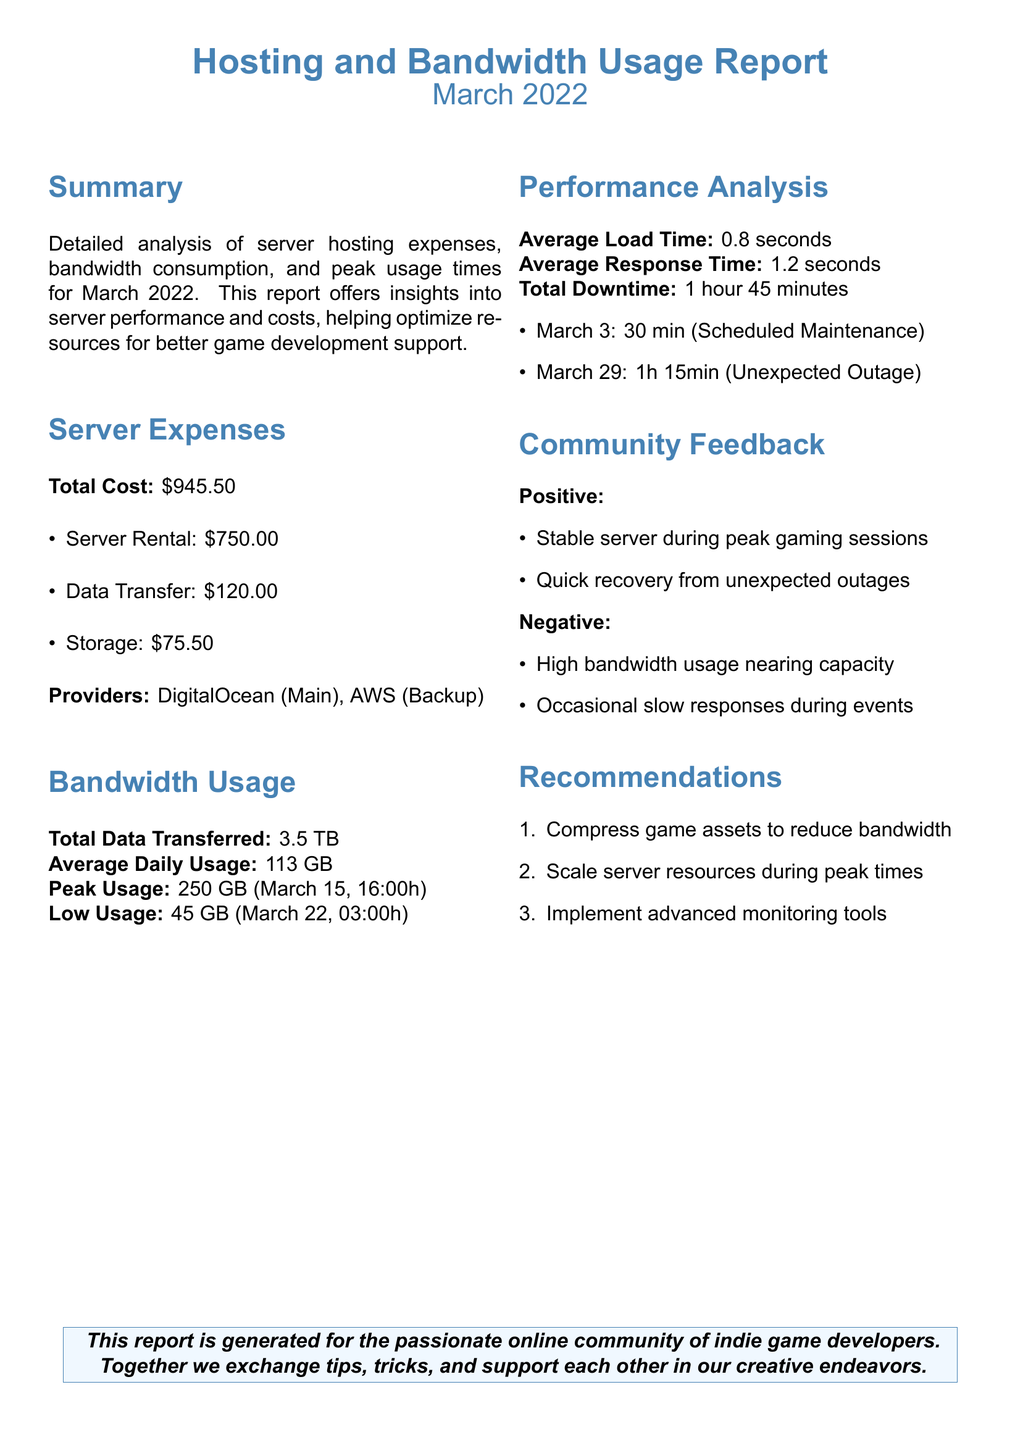what is the total cost of server hosting? The total cost is provided in a section about Server Expenses, which sums the different costs listed.
Answer: $945.50 what is the average daily bandwidth usage? The average daily usage is calculated by dividing the total data transferred by the number of days in March.
Answer: 113 GB when did peak usage occur? The peak usage time is specified in the Bandwidth Usage section of the report.
Answer: March 15, 16:00h how long was the total downtime? The total downtime combines the scheduled maintenance and unexpected outage durations given in the Performance Analysis section.
Answer: 1 hour 45 minutes what is the main server provider? The primary provider for the server hosting is mentioned in the Server Expenses section.
Answer: DigitalOcean what is a recommendation for bandwidth reduction? Recommendations provided in the report suggest specific actions to optimize bandwidth and server resources.
Answer: Compress game assets to reduce bandwidth how much data was transferred in total? The total data transferred is listed in the Bandwidth Usage section.
Answer: 3.5 TB what was the lowest bandwidth usage recorded? The lowest bandwidth is specified with its date and time in the Bandwidth Usage section of the document.
Answer: 45 GB (March 22, 03:00h) 